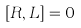Convert formula to latex. <formula><loc_0><loc_0><loc_500><loc_500>\left [ R , L \right ] = 0</formula> 